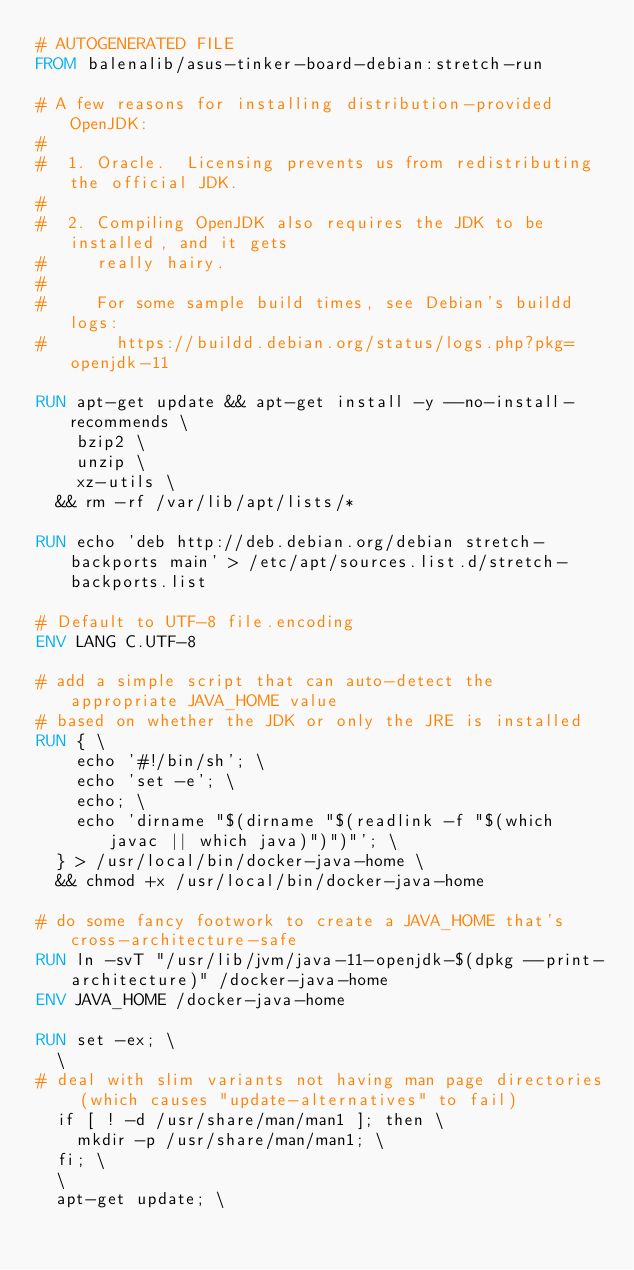<code> <loc_0><loc_0><loc_500><loc_500><_Dockerfile_># AUTOGENERATED FILE
FROM balenalib/asus-tinker-board-debian:stretch-run

# A few reasons for installing distribution-provided OpenJDK:
#
#  1. Oracle.  Licensing prevents us from redistributing the official JDK.
#
#  2. Compiling OpenJDK also requires the JDK to be installed, and it gets
#     really hairy.
#
#     For some sample build times, see Debian's buildd logs:
#       https://buildd.debian.org/status/logs.php?pkg=openjdk-11

RUN apt-get update && apt-get install -y --no-install-recommends \
		bzip2 \
		unzip \
		xz-utils \
	&& rm -rf /var/lib/apt/lists/*

RUN echo 'deb http://deb.debian.org/debian stretch-backports main' > /etc/apt/sources.list.d/stretch-backports.list

# Default to UTF-8 file.encoding
ENV LANG C.UTF-8

# add a simple script that can auto-detect the appropriate JAVA_HOME value
# based on whether the JDK or only the JRE is installed
RUN { \
		echo '#!/bin/sh'; \
		echo 'set -e'; \
		echo; \
		echo 'dirname "$(dirname "$(readlink -f "$(which javac || which java)")")"'; \
	} > /usr/local/bin/docker-java-home \
	&& chmod +x /usr/local/bin/docker-java-home

# do some fancy footwork to create a JAVA_HOME that's cross-architecture-safe
RUN ln -svT "/usr/lib/jvm/java-11-openjdk-$(dpkg --print-architecture)" /docker-java-home
ENV JAVA_HOME /docker-java-home

RUN set -ex; \
	\
# deal with slim variants not having man page directories (which causes "update-alternatives" to fail)
	if [ ! -d /usr/share/man/man1 ]; then \
		mkdir -p /usr/share/man/man1; \
	fi; \
	\
	apt-get update; \</code> 